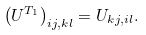<formula> <loc_0><loc_0><loc_500><loc_500>\left ( U ^ { T _ { 1 } } \right ) _ { i j , k l } = U _ { k j , i l } .</formula> 